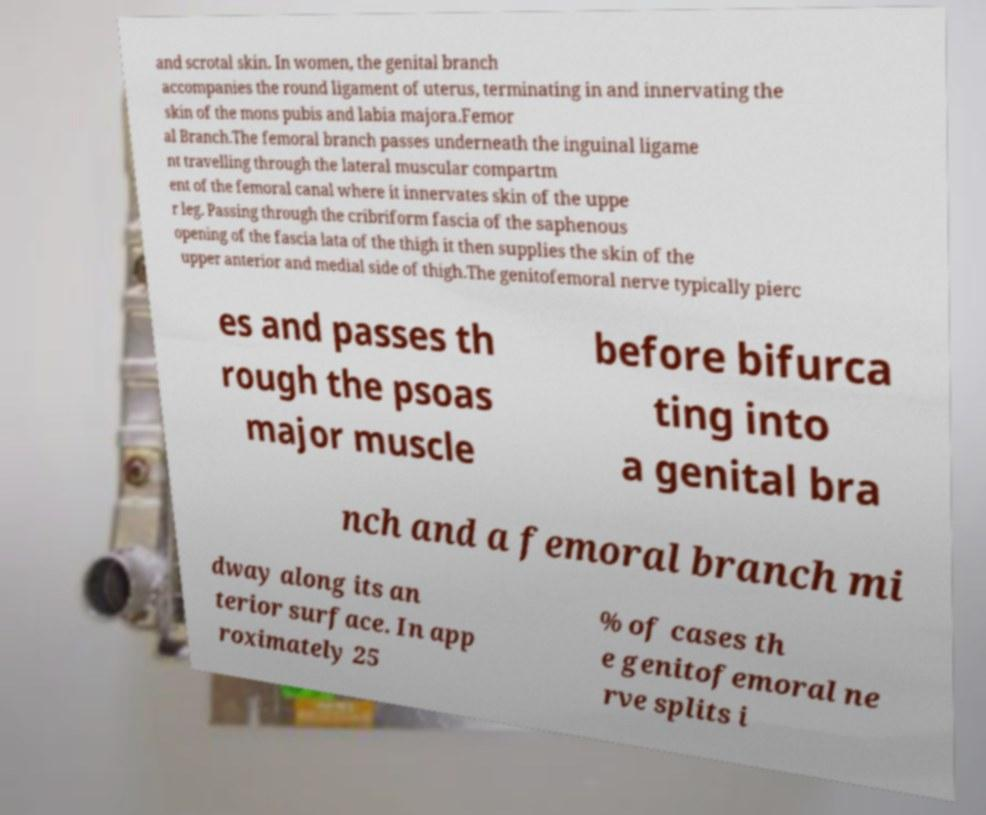Please read and relay the text visible in this image. What does it say? and scrotal skin. In women, the genital branch accompanies the round ligament of uterus, terminating in and innervating the skin of the mons pubis and labia majora.Femor al Branch.The femoral branch passes underneath the inguinal ligame nt travelling through the lateral muscular compartm ent of the femoral canal where it innervates skin of the uppe r leg. Passing through the cribriform fascia of the saphenous opening of the fascia lata of the thigh it then supplies the skin of the upper anterior and medial side of thigh.The genitofemoral nerve typically pierc es and passes th rough the psoas major muscle before bifurca ting into a genital bra nch and a femoral branch mi dway along its an terior surface. In app roximately 25 % of cases th e genitofemoral ne rve splits i 